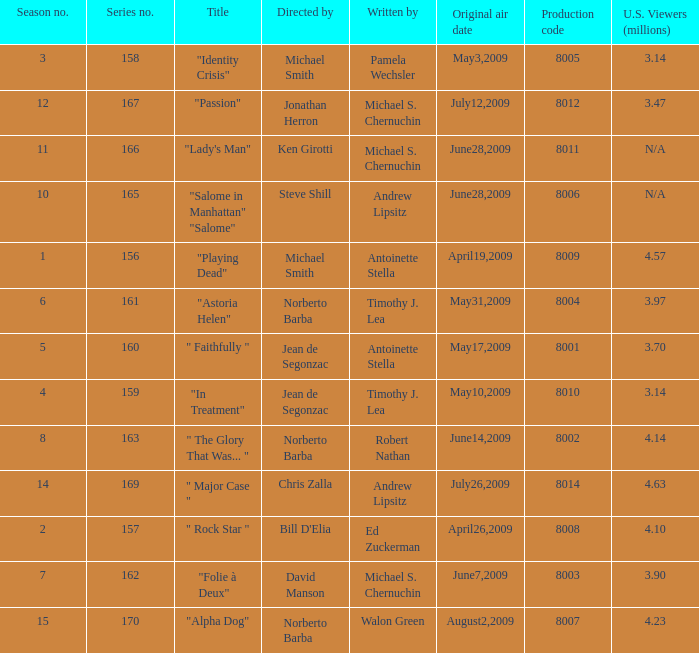Can you give me this table as a dict? {'header': ['Season no.', 'Series no.', 'Title', 'Directed by', 'Written by', 'Original air date', 'Production code', 'U.S. Viewers (millions)'], 'rows': [['3', '158', '"Identity Crisis"', 'Michael Smith', 'Pamela Wechsler', 'May3,2009', '8005', '3.14'], ['12', '167', '"Passion"', 'Jonathan Herron', 'Michael S. Chernuchin', 'July12,2009', '8012', '3.47'], ['11', '166', '"Lady\'s Man"', 'Ken Girotti', 'Michael S. Chernuchin', 'June28,2009', '8011', 'N/A'], ['10', '165', '"Salome in Manhattan" "Salome"', 'Steve Shill', 'Andrew Lipsitz', 'June28,2009', '8006', 'N/A'], ['1', '156', '"Playing Dead"', 'Michael Smith', 'Antoinette Stella', 'April19,2009', '8009', '4.57'], ['6', '161', '"Astoria Helen"', 'Norberto Barba', 'Timothy J. Lea', 'May31,2009', '8004', '3.97'], ['5', '160', '" Faithfully "', 'Jean de Segonzac', 'Antoinette Stella', 'May17,2009', '8001', '3.70'], ['4', '159', '"In Treatment"', 'Jean de Segonzac', 'Timothy J. Lea', 'May10,2009', '8010', '3.14'], ['8', '163', '" The Glory That Was... "', 'Norberto Barba', 'Robert Nathan', 'June14,2009', '8002', '4.14'], ['14', '169', '" Major Case "', 'Chris Zalla', 'Andrew Lipsitz', 'July26,2009', '8014', '4.63'], ['2', '157', '" Rock Star "', "Bill D'Elia", 'Ed Zuckerman', 'April26,2009', '8008', '4.10'], ['7', '162', '"Folie à Deux"', 'David Manson', 'Michael S. Chernuchin', 'June7,2009', '8003', '3.90'], ['15', '170', '"Alpha Dog"', 'Norberto Barba', 'Walon Green', 'August2,2009', '8007', '4.23']]} What is the name of the episode whose writer is timothy j. lea and the director is norberto barba? "Astoria Helen". 